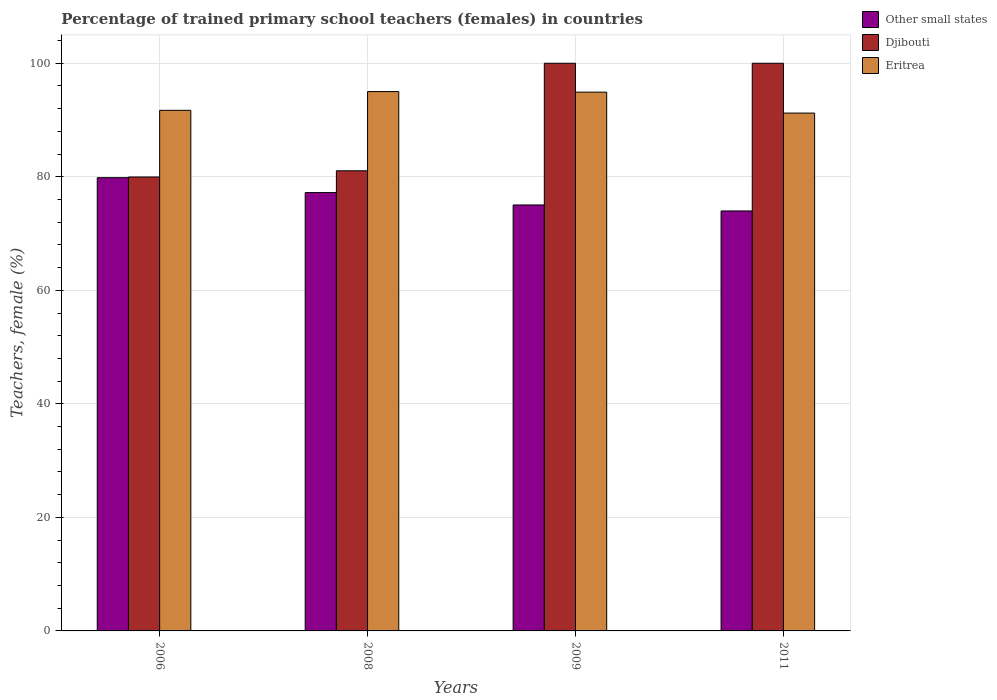How many different coloured bars are there?
Provide a short and direct response. 3. How many groups of bars are there?
Give a very brief answer. 4. How many bars are there on the 2nd tick from the left?
Your answer should be very brief. 3. Across all years, what is the minimum percentage of trained primary school teachers (females) in Other small states?
Keep it short and to the point. 73.98. What is the total percentage of trained primary school teachers (females) in Djibouti in the graph?
Offer a very short reply. 361.02. What is the difference between the percentage of trained primary school teachers (females) in Other small states in 2006 and that in 2011?
Provide a succinct answer. 5.86. What is the difference between the percentage of trained primary school teachers (females) in Eritrea in 2008 and the percentage of trained primary school teachers (females) in Djibouti in 2011?
Your response must be concise. -4.99. What is the average percentage of trained primary school teachers (females) in Eritrea per year?
Keep it short and to the point. 93.21. In the year 2011, what is the difference between the percentage of trained primary school teachers (females) in Other small states and percentage of trained primary school teachers (females) in Eritrea?
Provide a succinct answer. -17.24. What is the ratio of the percentage of trained primary school teachers (females) in Djibouti in 2006 to that in 2011?
Your answer should be compact. 0.8. Is the percentage of trained primary school teachers (females) in Eritrea in 2008 less than that in 2011?
Provide a short and direct response. No. What is the difference between the highest and the second highest percentage of trained primary school teachers (females) in Djibouti?
Keep it short and to the point. 0. What is the difference between the highest and the lowest percentage of trained primary school teachers (females) in Eritrea?
Your answer should be compact. 3.79. In how many years, is the percentage of trained primary school teachers (females) in Eritrea greater than the average percentage of trained primary school teachers (females) in Eritrea taken over all years?
Your answer should be compact. 2. What does the 2nd bar from the left in 2008 represents?
Your answer should be compact. Djibouti. What does the 2nd bar from the right in 2008 represents?
Provide a short and direct response. Djibouti. Is it the case that in every year, the sum of the percentage of trained primary school teachers (females) in Eritrea and percentage of trained primary school teachers (females) in Other small states is greater than the percentage of trained primary school teachers (females) in Djibouti?
Give a very brief answer. Yes. How many bars are there?
Offer a very short reply. 12. Are all the bars in the graph horizontal?
Keep it short and to the point. No. How many legend labels are there?
Make the answer very short. 3. How are the legend labels stacked?
Offer a very short reply. Vertical. What is the title of the graph?
Keep it short and to the point. Percentage of trained primary school teachers (females) in countries. Does "Channel Islands" appear as one of the legend labels in the graph?
Your answer should be very brief. No. What is the label or title of the Y-axis?
Provide a succinct answer. Teachers, female (%). What is the Teachers, female (%) of Other small states in 2006?
Give a very brief answer. 79.84. What is the Teachers, female (%) of Djibouti in 2006?
Provide a short and direct response. 79.97. What is the Teachers, female (%) in Eritrea in 2006?
Your answer should be very brief. 91.71. What is the Teachers, female (%) in Other small states in 2008?
Your answer should be very brief. 77.22. What is the Teachers, female (%) in Djibouti in 2008?
Make the answer very short. 81.06. What is the Teachers, female (%) in Eritrea in 2008?
Offer a very short reply. 95.01. What is the Teachers, female (%) of Other small states in 2009?
Offer a very short reply. 75.04. What is the Teachers, female (%) of Eritrea in 2009?
Your response must be concise. 94.91. What is the Teachers, female (%) in Other small states in 2011?
Provide a short and direct response. 73.98. What is the Teachers, female (%) in Djibouti in 2011?
Give a very brief answer. 100. What is the Teachers, female (%) in Eritrea in 2011?
Your answer should be compact. 91.22. Across all years, what is the maximum Teachers, female (%) in Other small states?
Your response must be concise. 79.84. Across all years, what is the maximum Teachers, female (%) of Djibouti?
Give a very brief answer. 100. Across all years, what is the maximum Teachers, female (%) of Eritrea?
Your response must be concise. 95.01. Across all years, what is the minimum Teachers, female (%) in Other small states?
Your response must be concise. 73.98. Across all years, what is the minimum Teachers, female (%) of Djibouti?
Your response must be concise. 79.97. Across all years, what is the minimum Teachers, female (%) of Eritrea?
Offer a terse response. 91.22. What is the total Teachers, female (%) in Other small states in the graph?
Offer a terse response. 306.08. What is the total Teachers, female (%) of Djibouti in the graph?
Offer a terse response. 361.02. What is the total Teachers, female (%) of Eritrea in the graph?
Make the answer very short. 372.86. What is the difference between the Teachers, female (%) in Other small states in 2006 and that in 2008?
Give a very brief answer. 2.63. What is the difference between the Teachers, female (%) in Djibouti in 2006 and that in 2008?
Give a very brief answer. -1.09. What is the difference between the Teachers, female (%) of Eritrea in 2006 and that in 2008?
Ensure brevity in your answer.  -3.3. What is the difference between the Teachers, female (%) of Other small states in 2006 and that in 2009?
Offer a very short reply. 4.81. What is the difference between the Teachers, female (%) in Djibouti in 2006 and that in 2009?
Ensure brevity in your answer.  -20.03. What is the difference between the Teachers, female (%) of Eritrea in 2006 and that in 2009?
Offer a very short reply. -3.2. What is the difference between the Teachers, female (%) in Other small states in 2006 and that in 2011?
Provide a short and direct response. 5.86. What is the difference between the Teachers, female (%) of Djibouti in 2006 and that in 2011?
Your response must be concise. -20.03. What is the difference between the Teachers, female (%) in Eritrea in 2006 and that in 2011?
Your response must be concise. 0.49. What is the difference between the Teachers, female (%) in Other small states in 2008 and that in 2009?
Ensure brevity in your answer.  2.18. What is the difference between the Teachers, female (%) of Djibouti in 2008 and that in 2009?
Provide a short and direct response. -18.94. What is the difference between the Teachers, female (%) of Eritrea in 2008 and that in 2009?
Offer a terse response. 0.1. What is the difference between the Teachers, female (%) in Other small states in 2008 and that in 2011?
Offer a very short reply. 3.23. What is the difference between the Teachers, female (%) in Djibouti in 2008 and that in 2011?
Your answer should be compact. -18.94. What is the difference between the Teachers, female (%) in Eritrea in 2008 and that in 2011?
Offer a terse response. 3.79. What is the difference between the Teachers, female (%) in Other small states in 2009 and that in 2011?
Your answer should be very brief. 1.05. What is the difference between the Teachers, female (%) in Djibouti in 2009 and that in 2011?
Ensure brevity in your answer.  0. What is the difference between the Teachers, female (%) in Eritrea in 2009 and that in 2011?
Your answer should be compact. 3.69. What is the difference between the Teachers, female (%) in Other small states in 2006 and the Teachers, female (%) in Djibouti in 2008?
Your response must be concise. -1.21. What is the difference between the Teachers, female (%) of Other small states in 2006 and the Teachers, female (%) of Eritrea in 2008?
Offer a very short reply. -15.17. What is the difference between the Teachers, female (%) of Djibouti in 2006 and the Teachers, female (%) of Eritrea in 2008?
Your answer should be very brief. -15.05. What is the difference between the Teachers, female (%) in Other small states in 2006 and the Teachers, female (%) in Djibouti in 2009?
Offer a very short reply. -20.16. What is the difference between the Teachers, female (%) in Other small states in 2006 and the Teachers, female (%) in Eritrea in 2009?
Give a very brief answer. -15.07. What is the difference between the Teachers, female (%) of Djibouti in 2006 and the Teachers, female (%) of Eritrea in 2009?
Your response must be concise. -14.95. What is the difference between the Teachers, female (%) in Other small states in 2006 and the Teachers, female (%) in Djibouti in 2011?
Your answer should be very brief. -20.16. What is the difference between the Teachers, female (%) of Other small states in 2006 and the Teachers, female (%) of Eritrea in 2011?
Provide a succinct answer. -11.38. What is the difference between the Teachers, female (%) of Djibouti in 2006 and the Teachers, female (%) of Eritrea in 2011?
Offer a very short reply. -11.26. What is the difference between the Teachers, female (%) of Other small states in 2008 and the Teachers, female (%) of Djibouti in 2009?
Your response must be concise. -22.78. What is the difference between the Teachers, female (%) in Other small states in 2008 and the Teachers, female (%) in Eritrea in 2009?
Your response must be concise. -17.69. What is the difference between the Teachers, female (%) in Djibouti in 2008 and the Teachers, female (%) in Eritrea in 2009?
Your answer should be compact. -13.86. What is the difference between the Teachers, female (%) of Other small states in 2008 and the Teachers, female (%) of Djibouti in 2011?
Give a very brief answer. -22.78. What is the difference between the Teachers, female (%) of Other small states in 2008 and the Teachers, female (%) of Eritrea in 2011?
Give a very brief answer. -14.01. What is the difference between the Teachers, female (%) of Djibouti in 2008 and the Teachers, female (%) of Eritrea in 2011?
Keep it short and to the point. -10.17. What is the difference between the Teachers, female (%) of Other small states in 2009 and the Teachers, female (%) of Djibouti in 2011?
Ensure brevity in your answer.  -24.96. What is the difference between the Teachers, female (%) in Other small states in 2009 and the Teachers, female (%) in Eritrea in 2011?
Your response must be concise. -16.19. What is the difference between the Teachers, female (%) of Djibouti in 2009 and the Teachers, female (%) of Eritrea in 2011?
Provide a short and direct response. 8.78. What is the average Teachers, female (%) in Other small states per year?
Your response must be concise. 76.52. What is the average Teachers, female (%) in Djibouti per year?
Give a very brief answer. 90.26. What is the average Teachers, female (%) of Eritrea per year?
Give a very brief answer. 93.21. In the year 2006, what is the difference between the Teachers, female (%) in Other small states and Teachers, female (%) in Djibouti?
Provide a succinct answer. -0.12. In the year 2006, what is the difference between the Teachers, female (%) in Other small states and Teachers, female (%) in Eritrea?
Give a very brief answer. -11.87. In the year 2006, what is the difference between the Teachers, female (%) of Djibouti and Teachers, female (%) of Eritrea?
Keep it short and to the point. -11.74. In the year 2008, what is the difference between the Teachers, female (%) of Other small states and Teachers, female (%) of Djibouti?
Ensure brevity in your answer.  -3.84. In the year 2008, what is the difference between the Teachers, female (%) in Other small states and Teachers, female (%) in Eritrea?
Keep it short and to the point. -17.8. In the year 2008, what is the difference between the Teachers, female (%) of Djibouti and Teachers, female (%) of Eritrea?
Your answer should be very brief. -13.96. In the year 2009, what is the difference between the Teachers, female (%) of Other small states and Teachers, female (%) of Djibouti?
Keep it short and to the point. -24.96. In the year 2009, what is the difference between the Teachers, female (%) in Other small states and Teachers, female (%) in Eritrea?
Ensure brevity in your answer.  -19.88. In the year 2009, what is the difference between the Teachers, female (%) in Djibouti and Teachers, female (%) in Eritrea?
Your response must be concise. 5.09. In the year 2011, what is the difference between the Teachers, female (%) of Other small states and Teachers, female (%) of Djibouti?
Make the answer very short. -26.02. In the year 2011, what is the difference between the Teachers, female (%) in Other small states and Teachers, female (%) in Eritrea?
Provide a short and direct response. -17.24. In the year 2011, what is the difference between the Teachers, female (%) of Djibouti and Teachers, female (%) of Eritrea?
Your answer should be very brief. 8.78. What is the ratio of the Teachers, female (%) of Other small states in 2006 to that in 2008?
Keep it short and to the point. 1.03. What is the ratio of the Teachers, female (%) in Djibouti in 2006 to that in 2008?
Your answer should be very brief. 0.99. What is the ratio of the Teachers, female (%) in Eritrea in 2006 to that in 2008?
Your response must be concise. 0.97. What is the ratio of the Teachers, female (%) of Other small states in 2006 to that in 2009?
Keep it short and to the point. 1.06. What is the ratio of the Teachers, female (%) of Djibouti in 2006 to that in 2009?
Give a very brief answer. 0.8. What is the ratio of the Teachers, female (%) in Eritrea in 2006 to that in 2009?
Keep it short and to the point. 0.97. What is the ratio of the Teachers, female (%) of Other small states in 2006 to that in 2011?
Offer a very short reply. 1.08. What is the ratio of the Teachers, female (%) in Djibouti in 2006 to that in 2011?
Provide a succinct answer. 0.8. What is the ratio of the Teachers, female (%) of Eritrea in 2006 to that in 2011?
Your answer should be compact. 1.01. What is the ratio of the Teachers, female (%) of Other small states in 2008 to that in 2009?
Ensure brevity in your answer.  1.03. What is the ratio of the Teachers, female (%) of Djibouti in 2008 to that in 2009?
Ensure brevity in your answer.  0.81. What is the ratio of the Teachers, female (%) in Other small states in 2008 to that in 2011?
Offer a very short reply. 1.04. What is the ratio of the Teachers, female (%) of Djibouti in 2008 to that in 2011?
Ensure brevity in your answer.  0.81. What is the ratio of the Teachers, female (%) in Eritrea in 2008 to that in 2011?
Keep it short and to the point. 1.04. What is the ratio of the Teachers, female (%) of Other small states in 2009 to that in 2011?
Provide a short and direct response. 1.01. What is the ratio of the Teachers, female (%) in Djibouti in 2009 to that in 2011?
Ensure brevity in your answer.  1. What is the ratio of the Teachers, female (%) in Eritrea in 2009 to that in 2011?
Give a very brief answer. 1.04. What is the difference between the highest and the second highest Teachers, female (%) of Other small states?
Your answer should be very brief. 2.63. What is the difference between the highest and the second highest Teachers, female (%) of Djibouti?
Your answer should be compact. 0. What is the difference between the highest and the second highest Teachers, female (%) of Eritrea?
Make the answer very short. 0.1. What is the difference between the highest and the lowest Teachers, female (%) in Other small states?
Make the answer very short. 5.86. What is the difference between the highest and the lowest Teachers, female (%) of Djibouti?
Offer a terse response. 20.03. What is the difference between the highest and the lowest Teachers, female (%) in Eritrea?
Give a very brief answer. 3.79. 